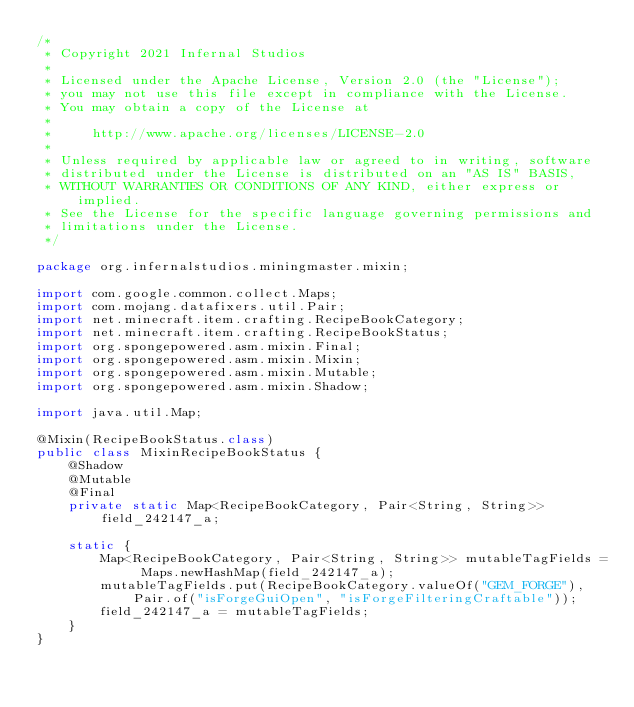Convert code to text. <code><loc_0><loc_0><loc_500><loc_500><_Java_>/*
 * Copyright 2021 Infernal Studios
 *
 * Licensed under the Apache License, Version 2.0 (the "License");
 * you may not use this file except in compliance with the License.
 * You may obtain a copy of the License at
 *
 *     http://www.apache.org/licenses/LICENSE-2.0
 *
 * Unless required by applicable law or agreed to in writing, software
 * distributed under the License is distributed on an "AS IS" BASIS,
 * WITHOUT WARRANTIES OR CONDITIONS OF ANY KIND, either express or implied.
 * See the License for the specific language governing permissions and
 * limitations under the License.
 */

package org.infernalstudios.miningmaster.mixin;

import com.google.common.collect.Maps;
import com.mojang.datafixers.util.Pair;
import net.minecraft.item.crafting.RecipeBookCategory;
import net.minecraft.item.crafting.RecipeBookStatus;
import org.spongepowered.asm.mixin.Final;
import org.spongepowered.asm.mixin.Mixin;
import org.spongepowered.asm.mixin.Mutable;
import org.spongepowered.asm.mixin.Shadow;

import java.util.Map;

@Mixin(RecipeBookStatus.class)
public class MixinRecipeBookStatus {
    @Shadow
    @Mutable
    @Final
    private static Map<RecipeBookCategory, Pair<String, String>> field_242147_a;

    static {
        Map<RecipeBookCategory, Pair<String, String>> mutableTagFields = Maps.newHashMap(field_242147_a);
        mutableTagFields.put(RecipeBookCategory.valueOf("GEM_FORGE"), Pair.of("isForgeGuiOpen", "isForgeFilteringCraftable"));
        field_242147_a = mutableTagFields;
    }
}
</code> 